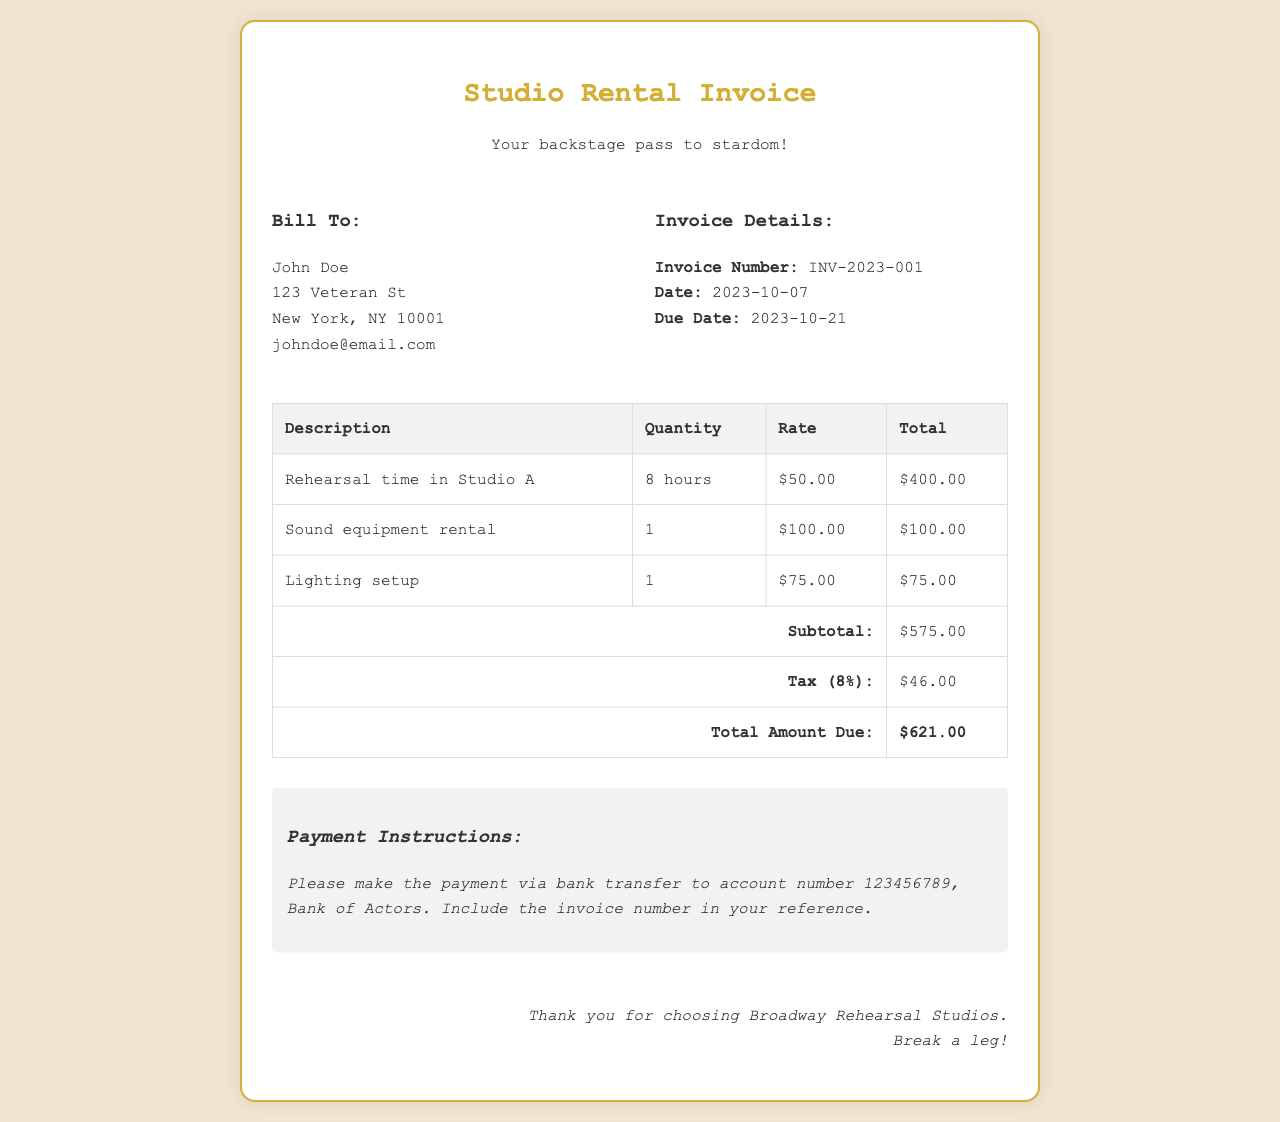What is the invoice number? The invoice number is located in the invoice details section, which uniquely identifies the invoice.
Answer: INV-2023-001 Who is the bill to? The 'Bill To' section provides the name and address of the client being invoiced.
Answer: John Doe What is the total amount due? The total amount due is calculated from the subtotal, taxes, and any other charges listed in the invoice.
Answer: $621.00 How many hours of rehearsal time were booked? The rehearsal time booked is specified in the table under the description for Studio A.
Answer: 8 hours What is the tax rate applied? The tax rate is stated in the invoice summary section under the tax description.
Answer: 8% What is the subtotal amount before tax? The subtotal is the sum of all itemized fees before tax is added, as shown in the invoice.
Answer: $575.00 What payment method is suggested? The payment instructions clearly specify how payment should be made in the invoice.
Answer: Bank transfer What is included in the additional amenities? The table lists what additional services or items were rented beyond the studio time.
Answer: Sound equipment rental, Lighting setup What is the due date for the payment? The due date is displayed in the invoice details section, indicating when the payment should be made.
Answer: 2023-10-21 